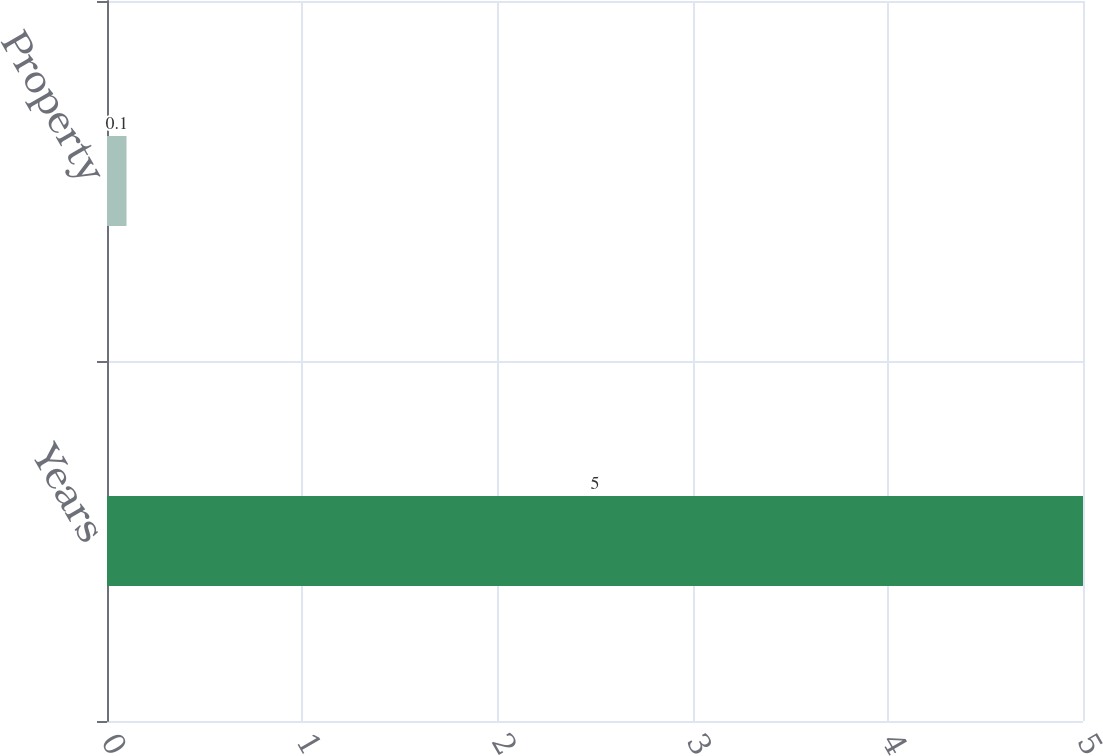Convert chart to OTSL. <chart><loc_0><loc_0><loc_500><loc_500><bar_chart><fcel>Years<fcel>Property<nl><fcel>5<fcel>0.1<nl></chart> 